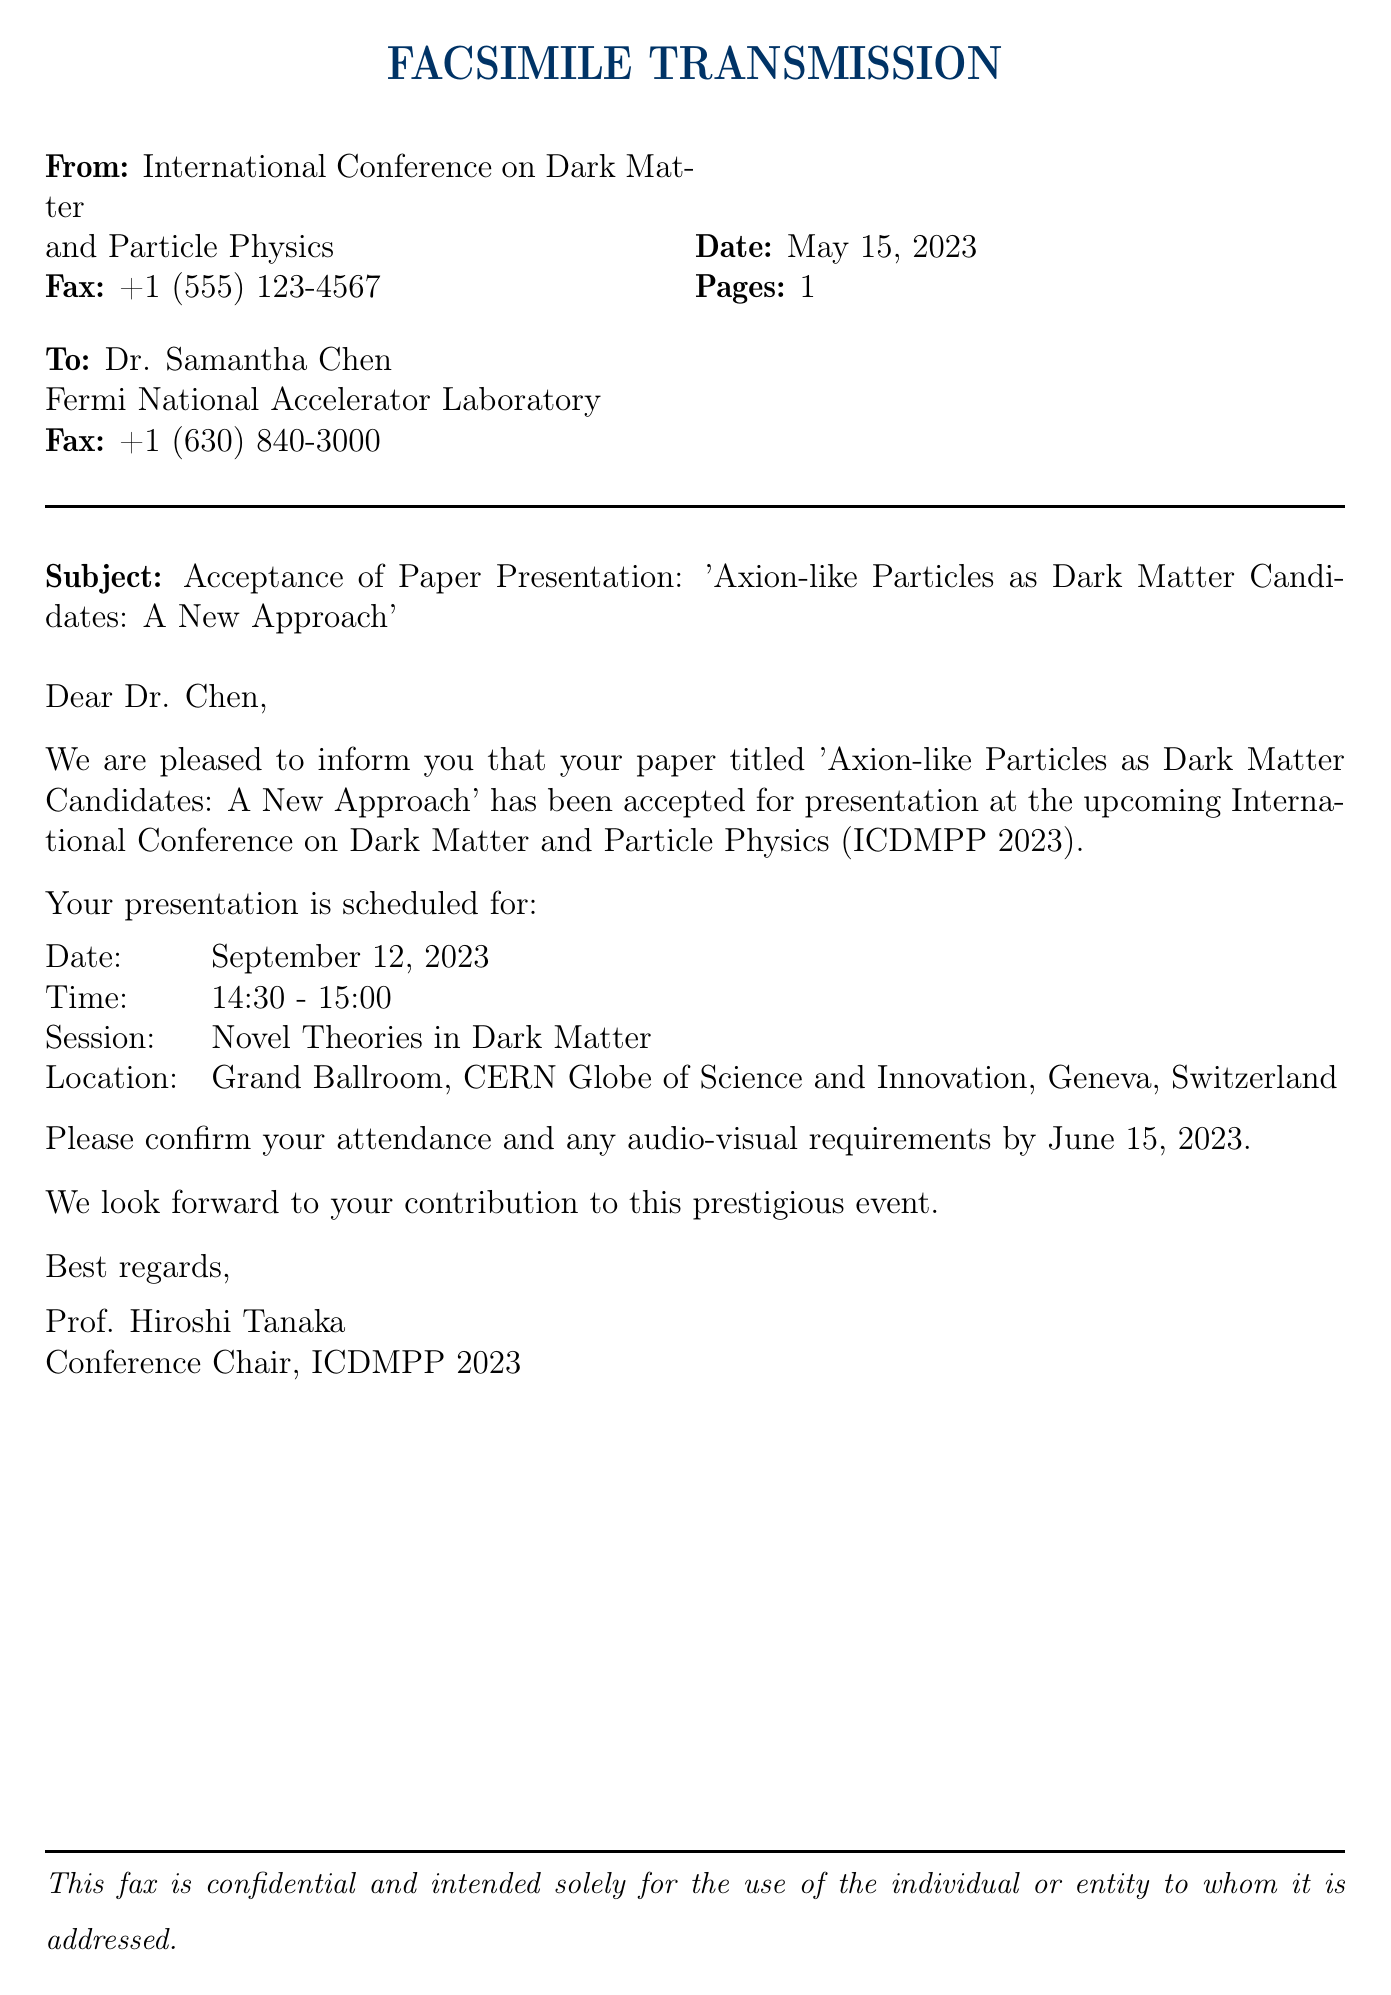What is the name of the conference? The name of the conference is mentioned in the subject line of the fax.
Answer: International Conference on Dark Matter and Particle Physics What is the title of the accepted paper? The title of the paper is stated clearly in the subject line of the fax.
Answer: Axion-like Particles as Dark Matter Candidates: A New Approach When is the presentation date? The date of the presentation is explicitly provided in the document.
Answer: September 12, 2023 What time is the presentation scheduled for? The time of the presentation is listed in the schedule section of the fax.
Answer: 14:30 - 15:00 Where will the conference take place? The location of the presentation is specified in the schedule section of the fax.
Answer: Grand Ballroom, CERN Globe of Science and Innovation, Geneva, Switzerland Who is the conference chair? The name of the conference chair is found in the signature section of the fax.
Answer: Prof. Hiroshi Tanaka By what date must the attendance be confirmed? The confirmation deadline is stated in the document.
Answer: June 15, 2023 What is the session title for the paper presentation? The title of the session is provided in the schedule section of the fax.
Answer: Novel Theories in Dark Matter How many pages is the fax? The number of pages is indicated in the fax header.
Answer: 1 